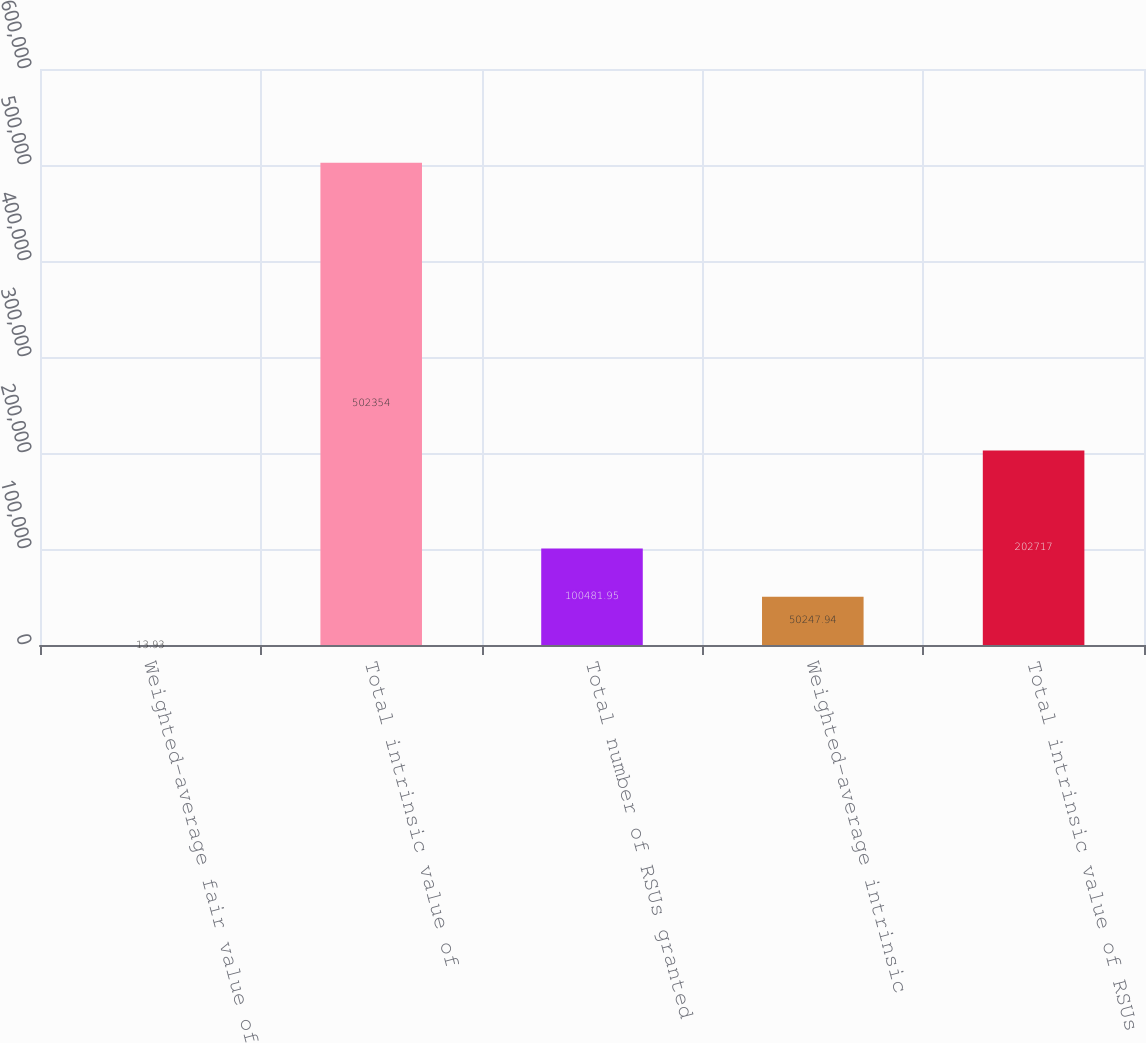<chart> <loc_0><loc_0><loc_500><loc_500><bar_chart><fcel>Weighted-average fair value of<fcel>Total intrinsic value of<fcel>Total number of RSUs granted<fcel>Weighted-average intrinsic<fcel>Total intrinsic value of RSUs<nl><fcel>13.93<fcel>502354<fcel>100482<fcel>50247.9<fcel>202717<nl></chart> 